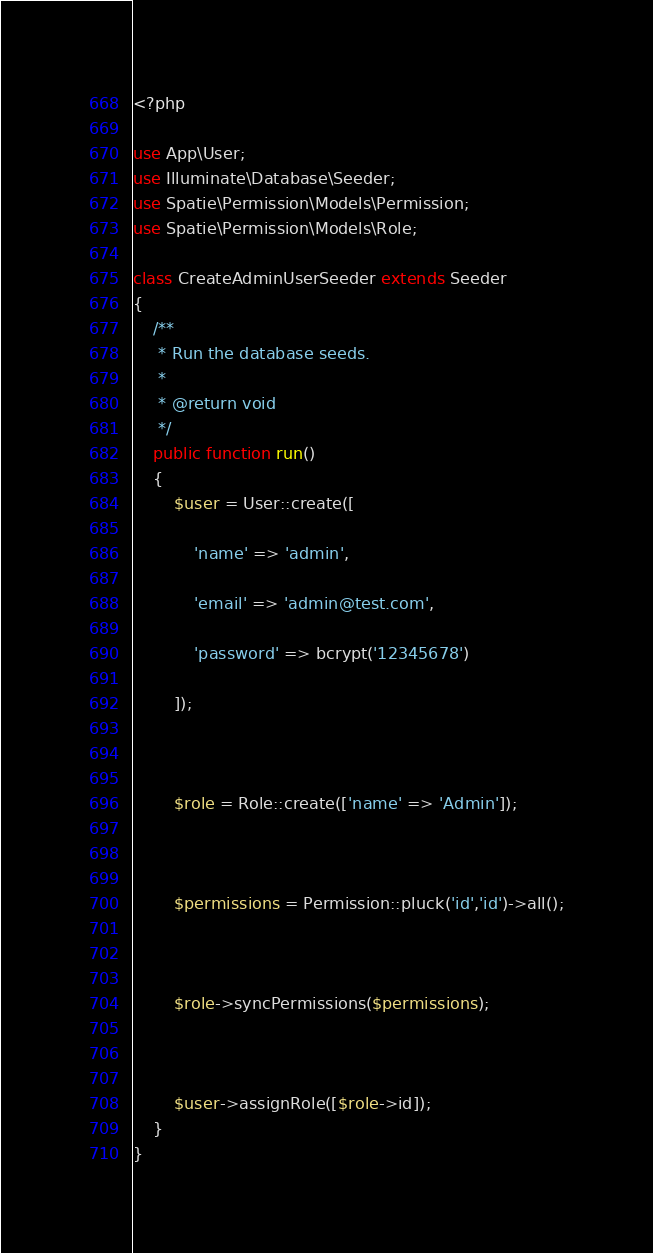Convert code to text. <code><loc_0><loc_0><loc_500><loc_500><_PHP_><?php

use App\User;
use Illuminate\Database\Seeder;
use Spatie\Permission\Models\Permission;
use Spatie\Permission\Models\Role;

class CreateAdminUserSeeder extends Seeder
{
    /**
     * Run the database seeds.
     *
     * @return void
     */
    public function run()
    {
        $user = User::create([

            'name' => 'admin',

            'email' => 'admin@test.com',

            'password' => bcrypt('12345678')

        ]);



        $role = Role::create(['name' => 'Admin']);



        $permissions = Permission::pluck('id','id')->all();



        $role->syncPermissions($permissions);



        $user->assignRole([$role->id]);
    }
}
</code> 